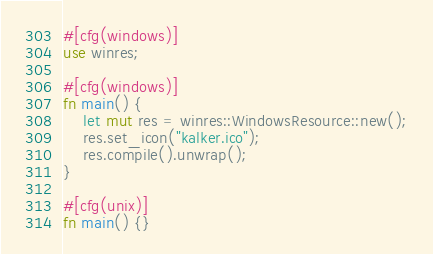Convert code to text. <code><loc_0><loc_0><loc_500><loc_500><_Rust_>#[cfg(windows)]
use winres;

#[cfg(windows)]
fn main() {
    let mut res = winres::WindowsResource::new();
    res.set_icon("kalker.ico");
    res.compile().unwrap();
}

#[cfg(unix)]
fn main() {}
</code> 